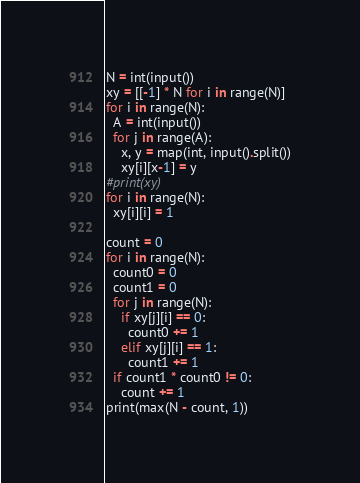<code> <loc_0><loc_0><loc_500><loc_500><_Python_>N = int(input())
xy = [[-1] * N for i in range(N)]
for i in range(N):
  A = int(input())
  for j in range(A):
    x, y = map(int, input().split())
    xy[i][x-1] = y
#print(xy)
for i in range(N):
  xy[i][i] = 1

count = 0
for i in range(N):
  count0 = 0
  count1 = 0
  for j in range(N):
    if xy[j][i] == 0:
      count0 += 1
    elif xy[j][i] == 1:
      count1 += 1
  if count1 * count0 != 0:
    count += 1
print(max(N - count, 1))
</code> 